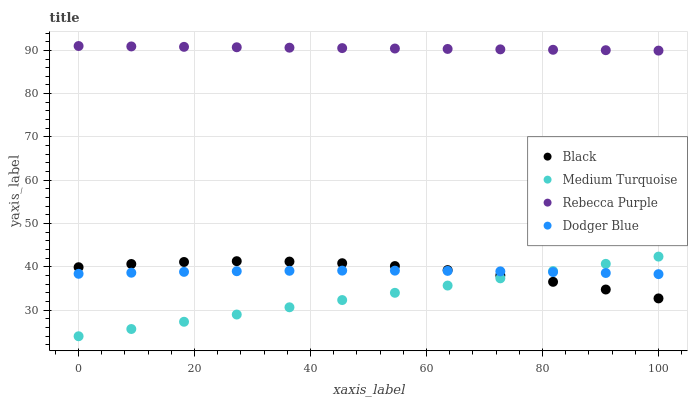Does Medium Turquoise have the minimum area under the curve?
Answer yes or no. Yes. Does Rebecca Purple have the maximum area under the curve?
Answer yes or no. Yes. Does Black have the minimum area under the curve?
Answer yes or no. No. Does Black have the maximum area under the curve?
Answer yes or no. No. Is Rebecca Purple the smoothest?
Answer yes or no. Yes. Is Black the roughest?
Answer yes or no. Yes. Is Black the smoothest?
Answer yes or no. No. Is Rebecca Purple the roughest?
Answer yes or no. No. Does Medium Turquoise have the lowest value?
Answer yes or no. Yes. Does Black have the lowest value?
Answer yes or no. No. Does Rebecca Purple have the highest value?
Answer yes or no. Yes. Does Black have the highest value?
Answer yes or no. No. Is Medium Turquoise less than Rebecca Purple?
Answer yes or no. Yes. Is Rebecca Purple greater than Black?
Answer yes or no. Yes. Does Medium Turquoise intersect Black?
Answer yes or no. Yes. Is Medium Turquoise less than Black?
Answer yes or no. No. Is Medium Turquoise greater than Black?
Answer yes or no. No. Does Medium Turquoise intersect Rebecca Purple?
Answer yes or no. No. 